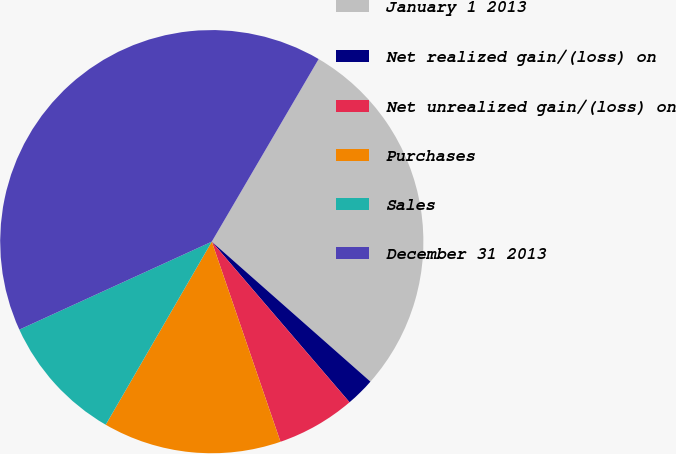Convert chart to OTSL. <chart><loc_0><loc_0><loc_500><loc_500><pie_chart><fcel>January 1 2013<fcel>Net realized gain/(loss) on<fcel>Net unrealized gain/(loss) on<fcel>Purchases<fcel>Sales<fcel>December 31 2013<nl><fcel>28.08%<fcel>2.21%<fcel>6.02%<fcel>13.62%<fcel>9.82%<fcel>40.25%<nl></chart> 